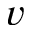Convert formula to latex. <formula><loc_0><loc_0><loc_500><loc_500>v</formula> 